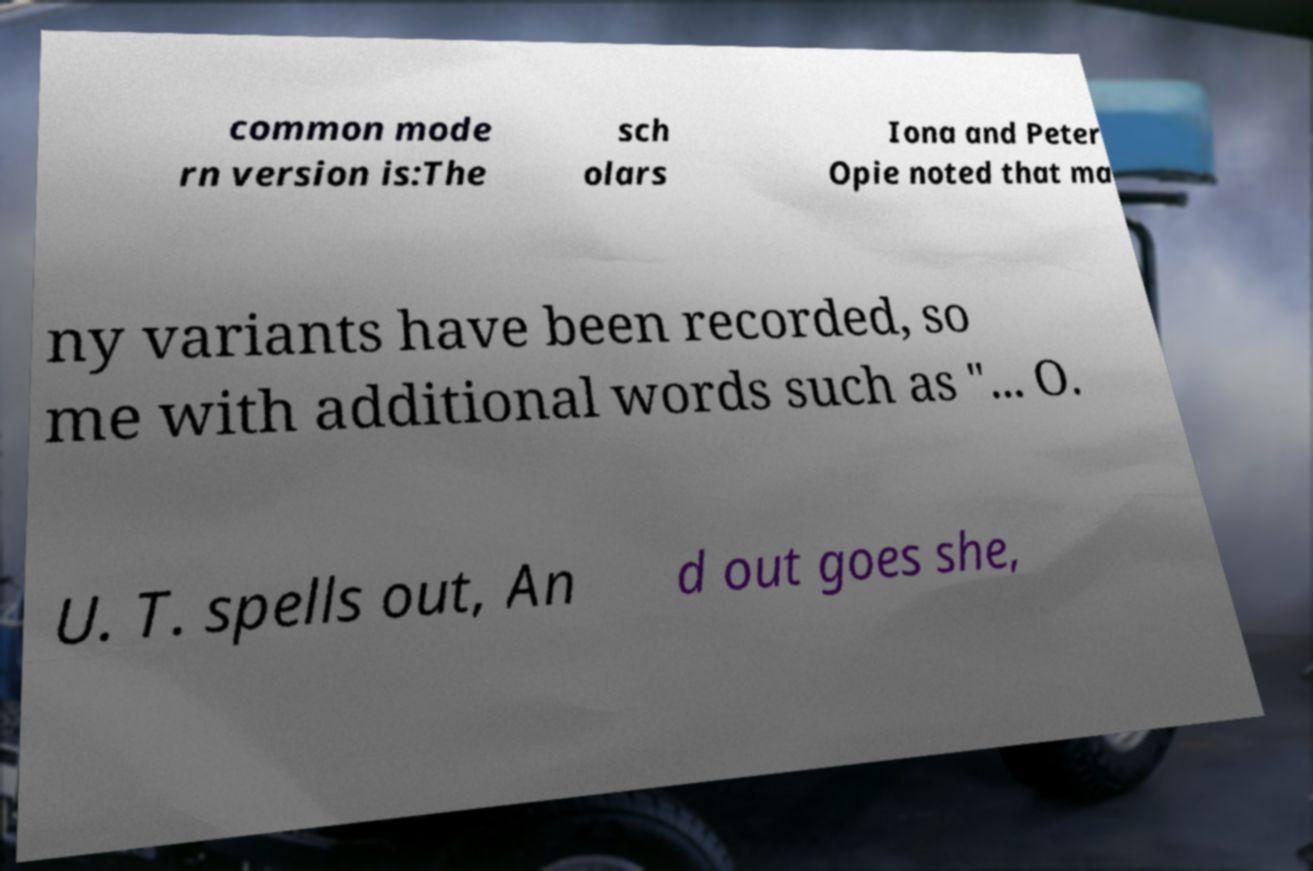There's text embedded in this image that I need extracted. Can you transcribe it verbatim? common mode rn version is:The sch olars Iona and Peter Opie noted that ma ny variants have been recorded, so me with additional words such as "... O. U. T. spells out, An d out goes she, 